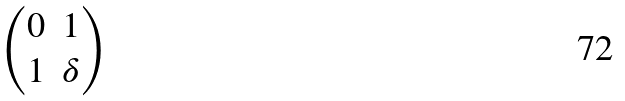Convert formula to latex. <formula><loc_0><loc_0><loc_500><loc_500>\begin{pmatrix} 0 & 1 \\ 1 & \delta \end{pmatrix}</formula> 